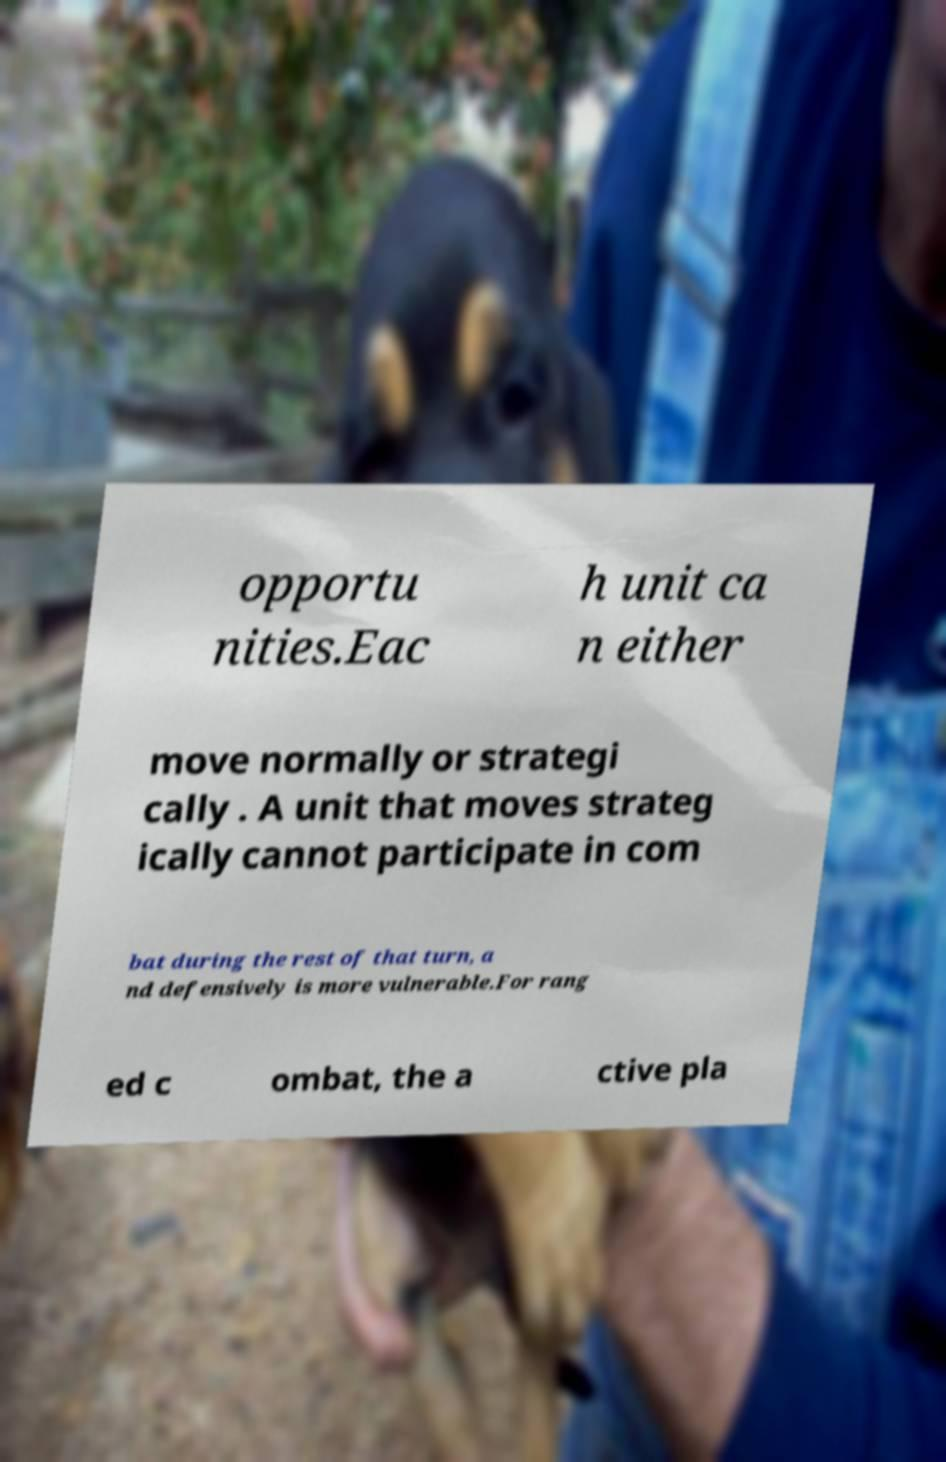Please identify and transcribe the text found in this image. opportu nities.Eac h unit ca n either move normally or strategi cally . A unit that moves strateg ically cannot participate in com bat during the rest of that turn, a nd defensively is more vulnerable.For rang ed c ombat, the a ctive pla 